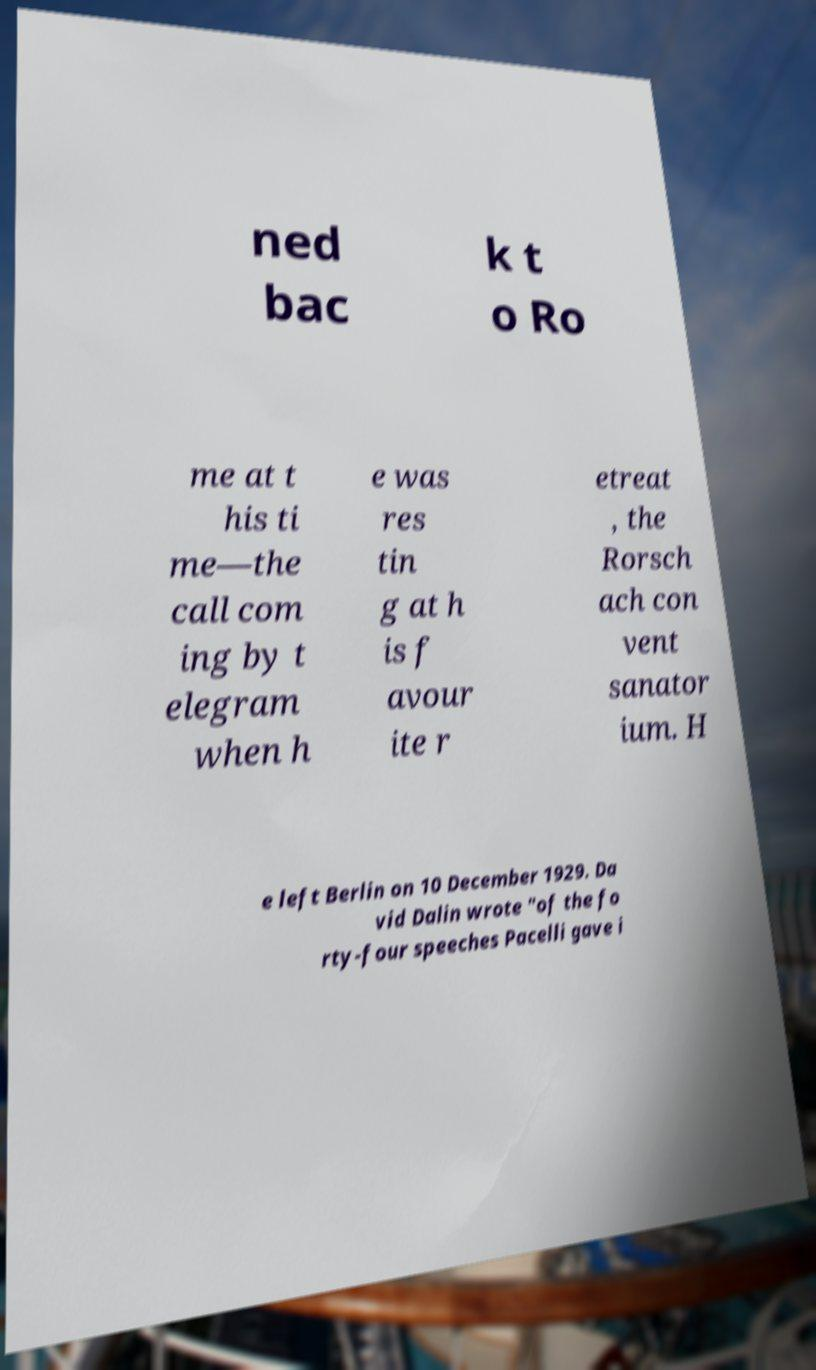Please identify and transcribe the text found in this image. ned bac k t o Ro me at t his ti me—the call com ing by t elegram when h e was res tin g at h is f avour ite r etreat , the Rorsch ach con vent sanator ium. H e left Berlin on 10 December 1929. Da vid Dalin wrote "of the fo rty-four speeches Pacelli gave i 